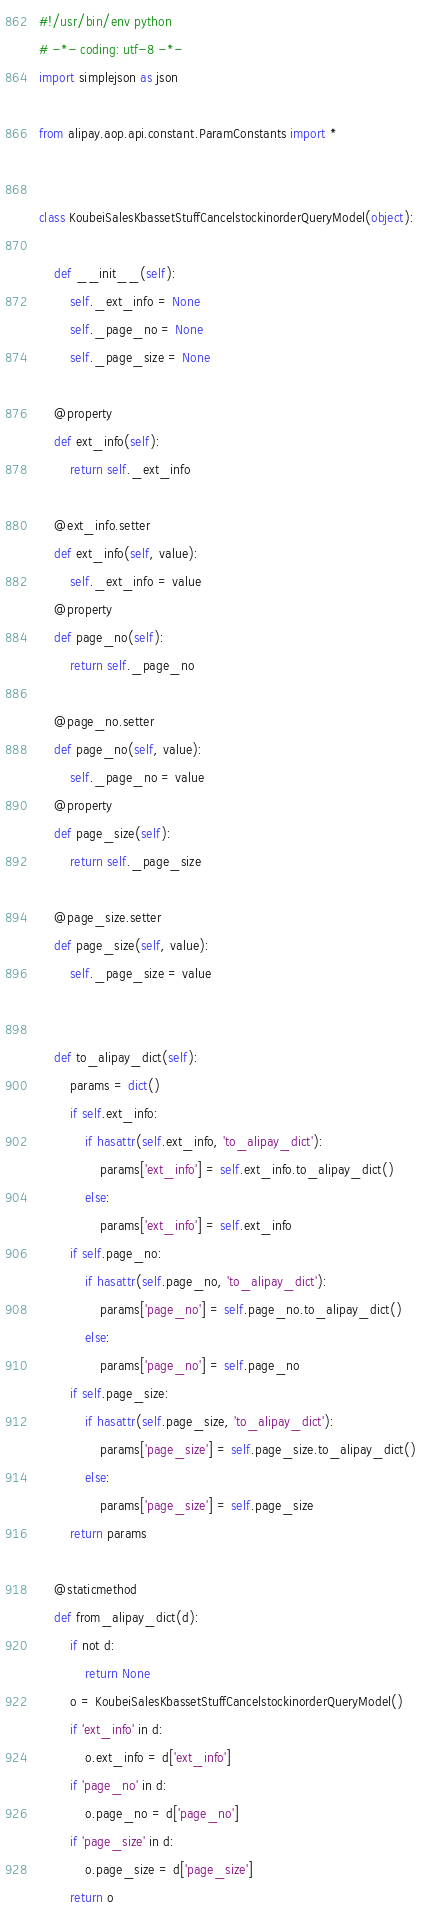Convert code to text. <code><loc_0><loc_0><loc_500><loc_500><_Python_>#!/usr/bin/env python
# -*- coding: utf-8 -*-
import simplejson as json

from alipay.aop.api.constant.ParamConstants import *


class KoubeiSalesKbassetStuffCancelstockinorderQueryModel(object):

    def __init__(self):
        self._ext_info = None
        self._page_no = None
        self._page_size = None

    @property
    def ext_info(self):
        return self._ext_info

    @ext_info.setter
    def ext_info(self, value):
        self._ext_info = value
    @property
    def page_no(self):
        return self._page_no

    @page_no.setter
    def page_no(self, value):
        self._page_no = value
    @property
    def page_size(self):
        return self._page_size

    @page_size.setter
    def page_size(self, value):
        self._page_size = value


    def to_alipay_dict(self):
        params = dict()
        if self.ext_info:
            if hasattr(self.ext_info, 'to_alipay_dict'):
                params['ext_info'] = self.ext_info.to_alipay_dict()
            else:
                params['ext_info'] = self.ext_info
        if self.page_no:
            if hasattr(self.page_no, 'to_alipay_dict'):
                params['page_no'] = self.page_no.to_alipay_dict()
            else:
                params['page_no'] = self.page_no
        if self.page_size:
            if hasattr(self.page_size, 'to_alipay_dict'):
                params['page_size'] = self.page_size.to_alipay_dict()
            else:
                params['page_size'] = self.page_size
        return params

    @staticmethod
    def from_alipay_dict(d):
        if not d:
            return None
        o = KoubeiSalesKbassetStuffCancelstockinorderQueryModel()
        if 'ext_info' in d:
            o.ext_info = d['ext_info']
        if 'page_no' in d:
            o.page_no = d['page_no']
        if 'page_size' in d:
            o.page_size = d['page_size']
        return o


</code> 